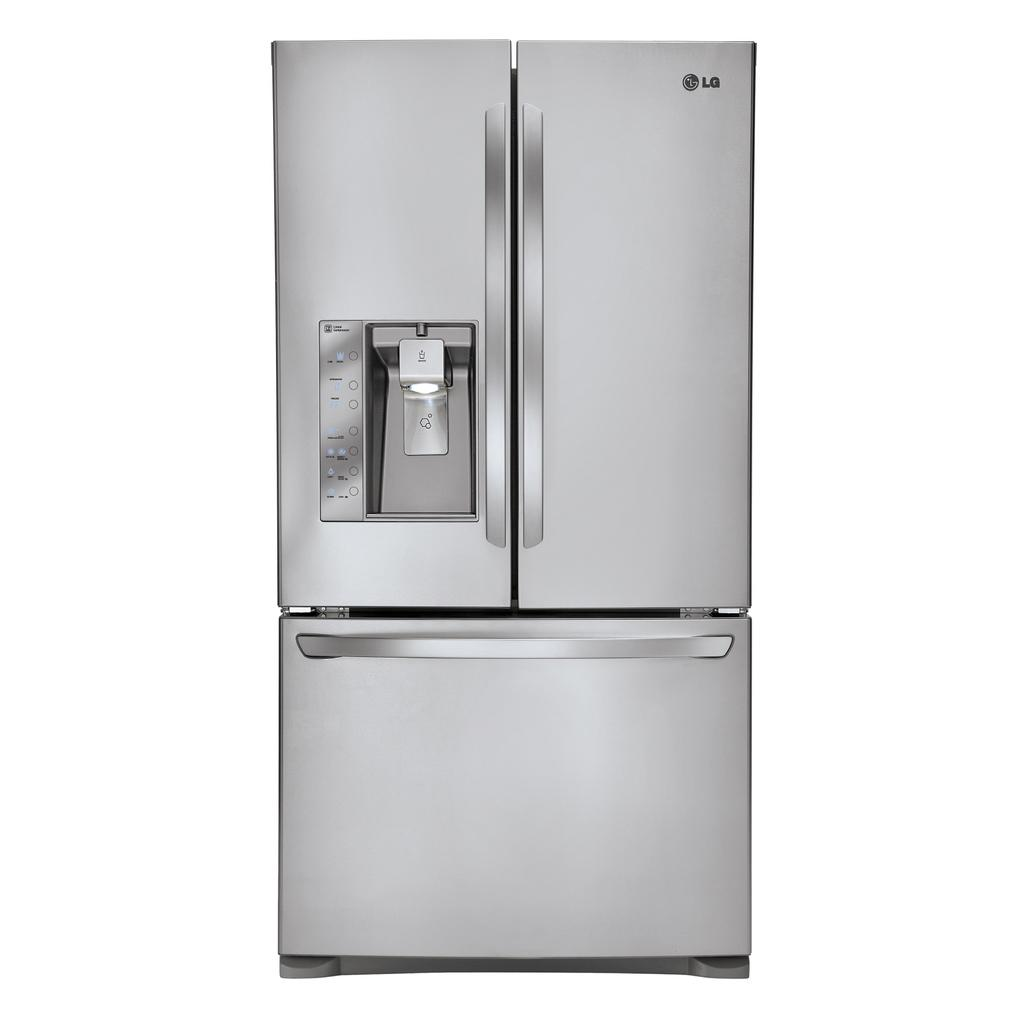<image>
Provide a brief description of the given image. A large stainless steel LG fridge with two upper doors and a lower compartment. 